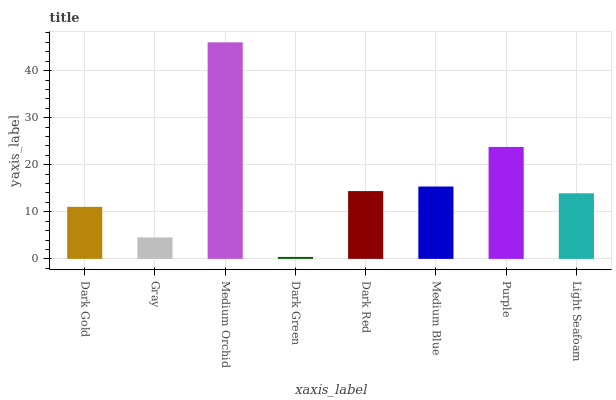Is Dark Green the minimum?
Answer yes or no. Yes. Is Medium Orchid the maximum?
Answer yes or no. Yes. Is Gray the minimum?
Answer yes or no. No. Is Gray the maximum?
Answer yes or no. No. Is Dark Gold greater than Gray?
Answer yes or no. Yes. Is Gray less than Dark Gold?
Answer yes or no. Yes. Is Gray greater than Dark Gold?
Answer yes or no. No. Is Dark Gold less than Gray?
Answer yes or no. No. Is Dark Red the high median?
Answer yes or no. Yes. Is Light Seafoam the low median?
Answer yes or no. Yes. Is Gray the high median?
Answer yes or no. No. Is Purple the low median?
Answer yes or no. No. 